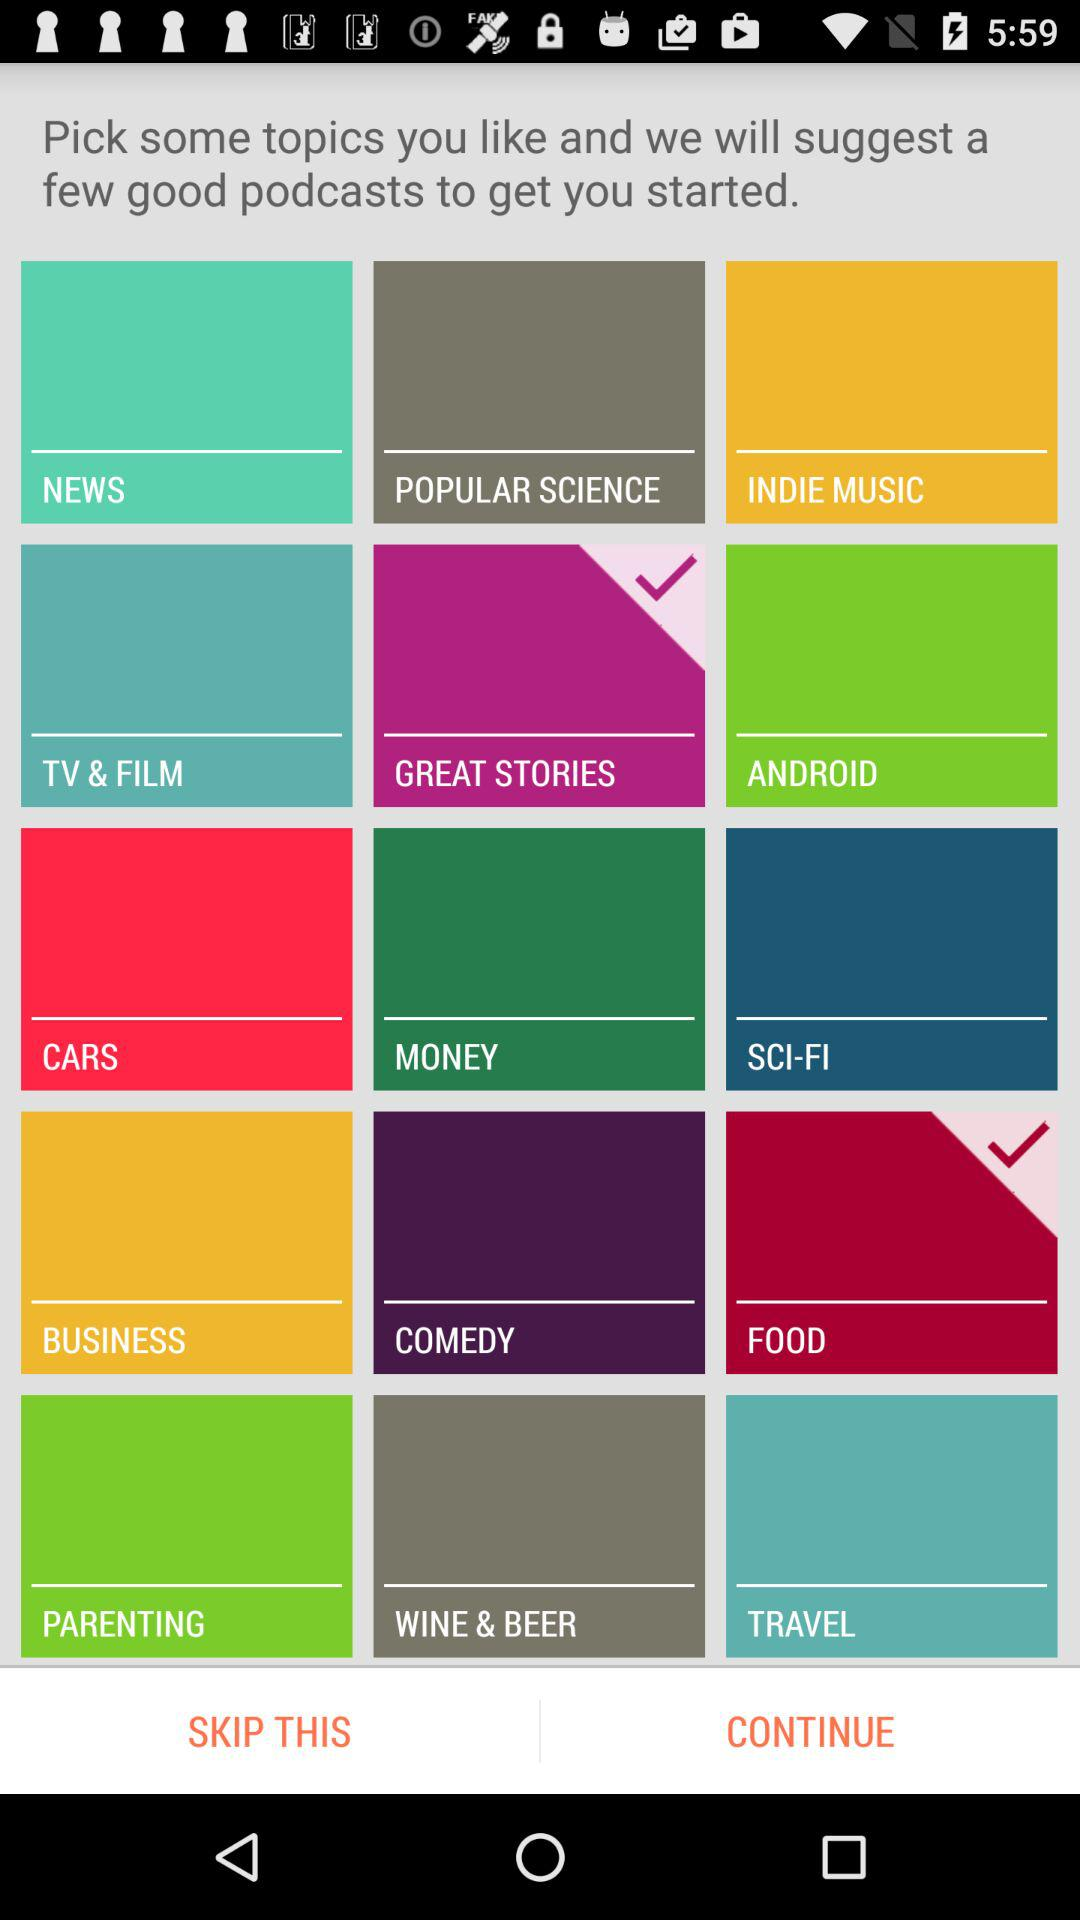How many topics have a check mark?
Answer the question using a single word or phrase. 2 